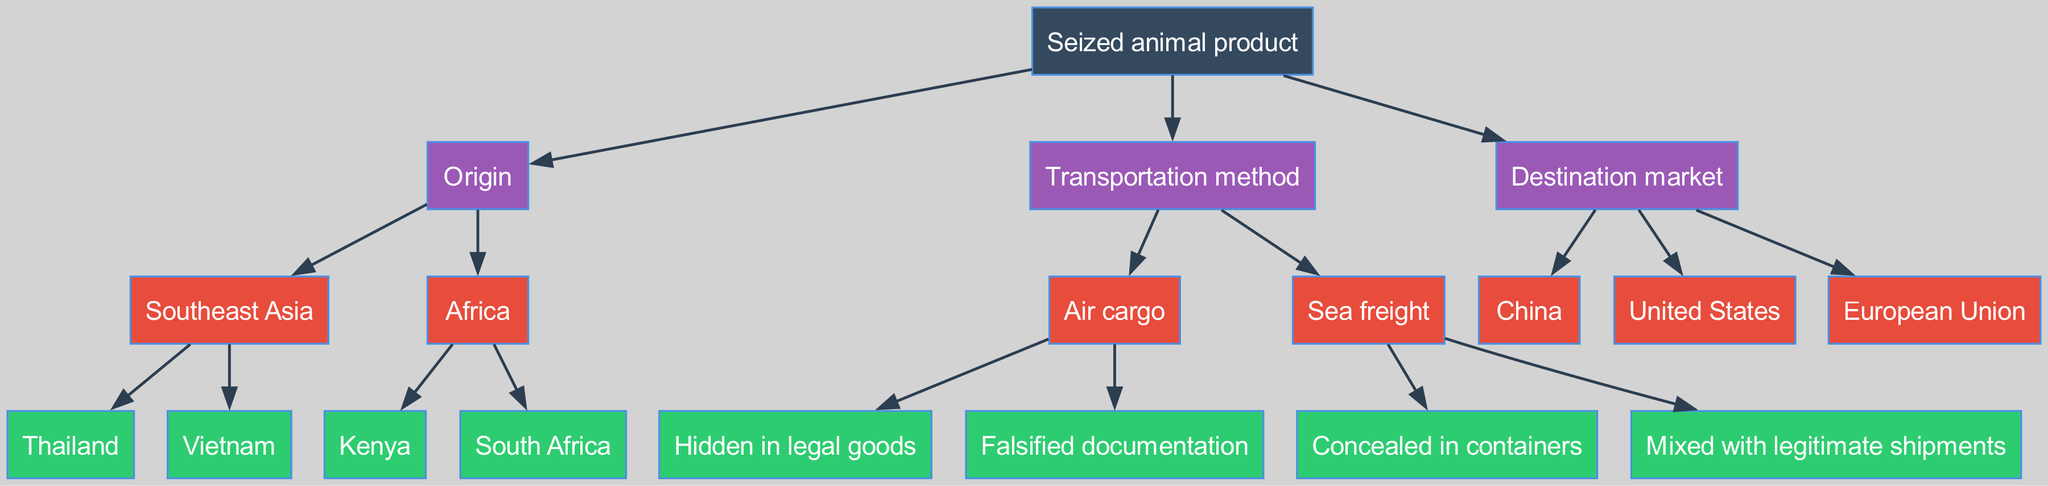What is the root node of the diagram? The root node is "Seized animal product," which is the starting point of the decision tree and provides the main category for further classification.
Answer: Seized animal product How many regions are specified for the origin of seized animal products? There are two regions listed under the "Origin" node: Southeast Asia and Africa, indicating the geographical sources of the products.
Answer: 2 What is one method of transportation mentioned in the diagram? The "Transportation method" node includes several methods, one of which is "Air cargo," representing how the seized animal products are transported.
Answer: Air cargo Which destination market is listed as a potential endpoint for seized products? The "Destination market" node includes options, one of which is "China," representing a key market for wildlife products.
Answer: China What is the relationship between "Thailand" and "Southeast Asia"? "Thailand" is a child node under "Southeast Asia," indicating that it is one of the specific origins of seized animal products within that broader geographic region.
Answer: Child node If seized products originate from "Africa," which specific countries are identified in the diagram? Under the "Africa" node, the specific countries cited are "Kenya" and "South Africa," indicating the direct sources of the animal products from that region.
Answer: Kenya, South Africa Which transportation method is associated with falsified documentation? The method that involves falsified documentation is "Air cargo," which suggests a way that traffickers might obscure the illegal nature of their shipments.
Answer: Air cargo How many different transportation methods are outlined in the diagram? There are two distinct transportation methods identified: "Air cargo" and "Sea freight," showing the means used to transport seized products.
Answer: 2 What color represents the "Transportation method" node in the diagram? The color for the "Transportation method" node is represented in the diagram as #9B59B6, distinguishing it from other categories.
Answer: #9B59B6 